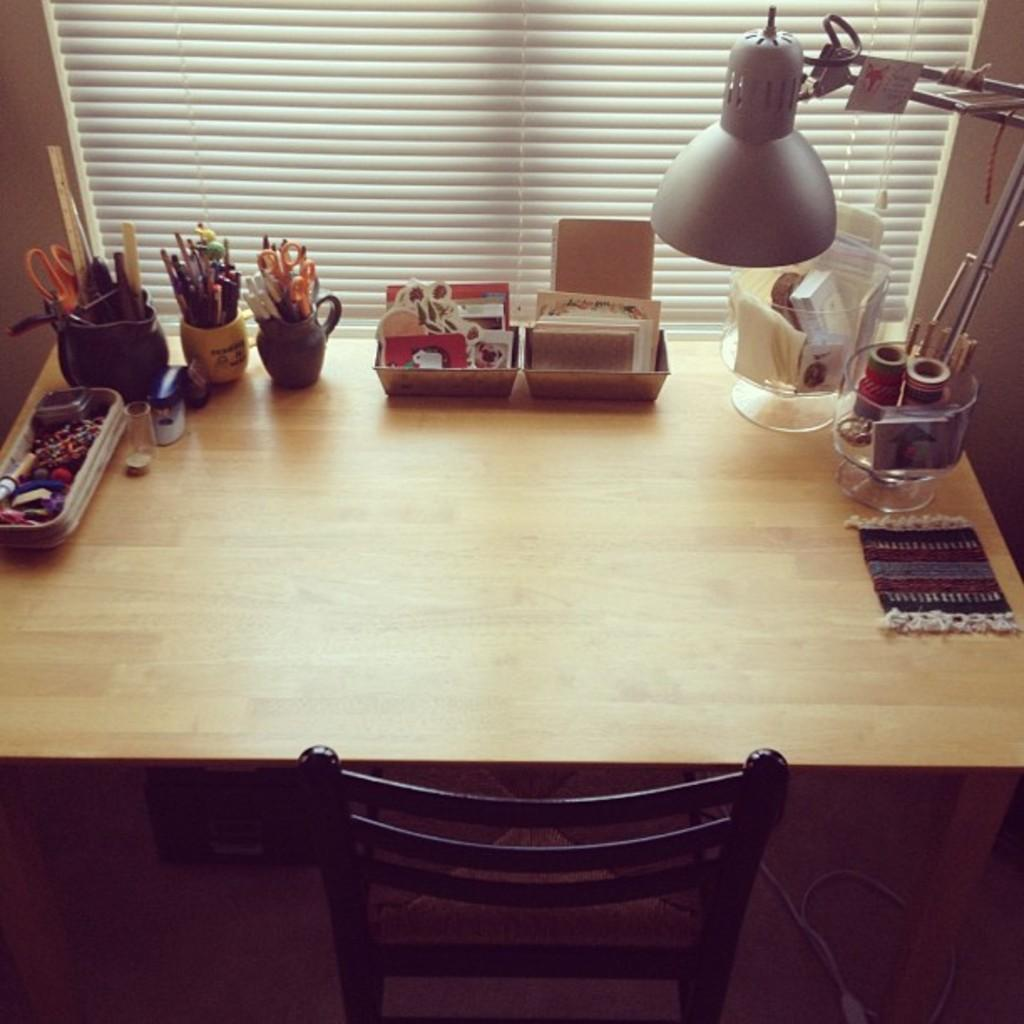What is located in the center of the image? There is a table in the center of the image. What can be found on the table? There are objects on the table. Is there any furniture besides the table in the image? Yes, there is a chair in the image. What can be seen in the background of the image? There is a window and a wall in the background of the image. What decision was made by the company in the image? There is no company or decision present in the image; it only features a table, objects on the table, a chair, a window, and a wall in the background. 